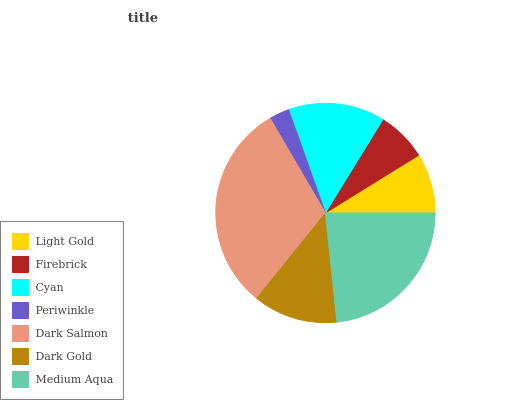Is Periwinkle the minimum?
Answer yes or no. Yes. Is Dark Salmon the maximum?
Answer yes or no. Yes. Is Firebrick the minimum?
Answer yes or no. No. Is Firebrick the maximum?
Answer yes or no. No. Is Light Gold greater than Firebrick?
Answer yes or no. Yes. Is Firebrick less than Light Gold?
Answer yes or no. Yes. Is Firebrick greater than Light Gold?
Answer yes or no. No. Is Light Gold less than Firebrick?
Answer yes or no. No. Is Dark Gold the high median?
Answer yes or no. Yes. Is Dark Gold the low median?
Answer yes or no. Yes. Is Light Gold the high median?
Answer yes or no. No. Is Dark Salmon the low median?
Answer yes or no. No. 